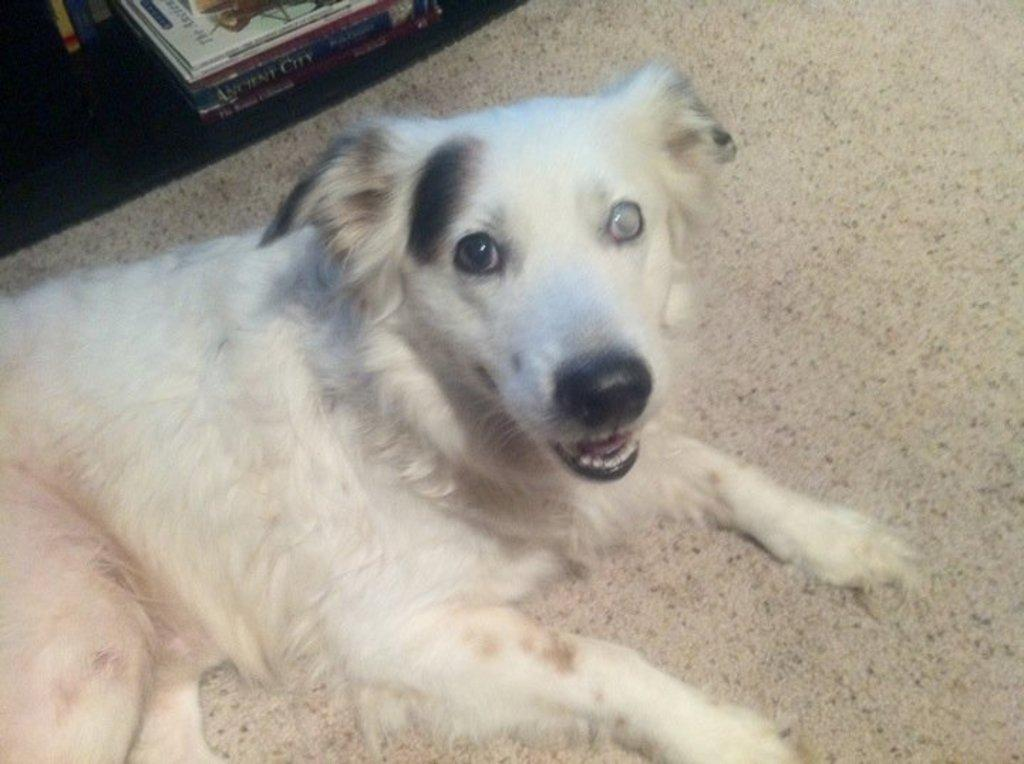What type of animal is in the image? There is a white dog in the image. What is the dog doing in the image? The dog is sitting on the ground. What else can be seen on the ground in the image? There are books and other objects on the ground. What type of poison is the dog consuming in the image? There is no poison present in the image; the dog is simply sitting on the ground. 